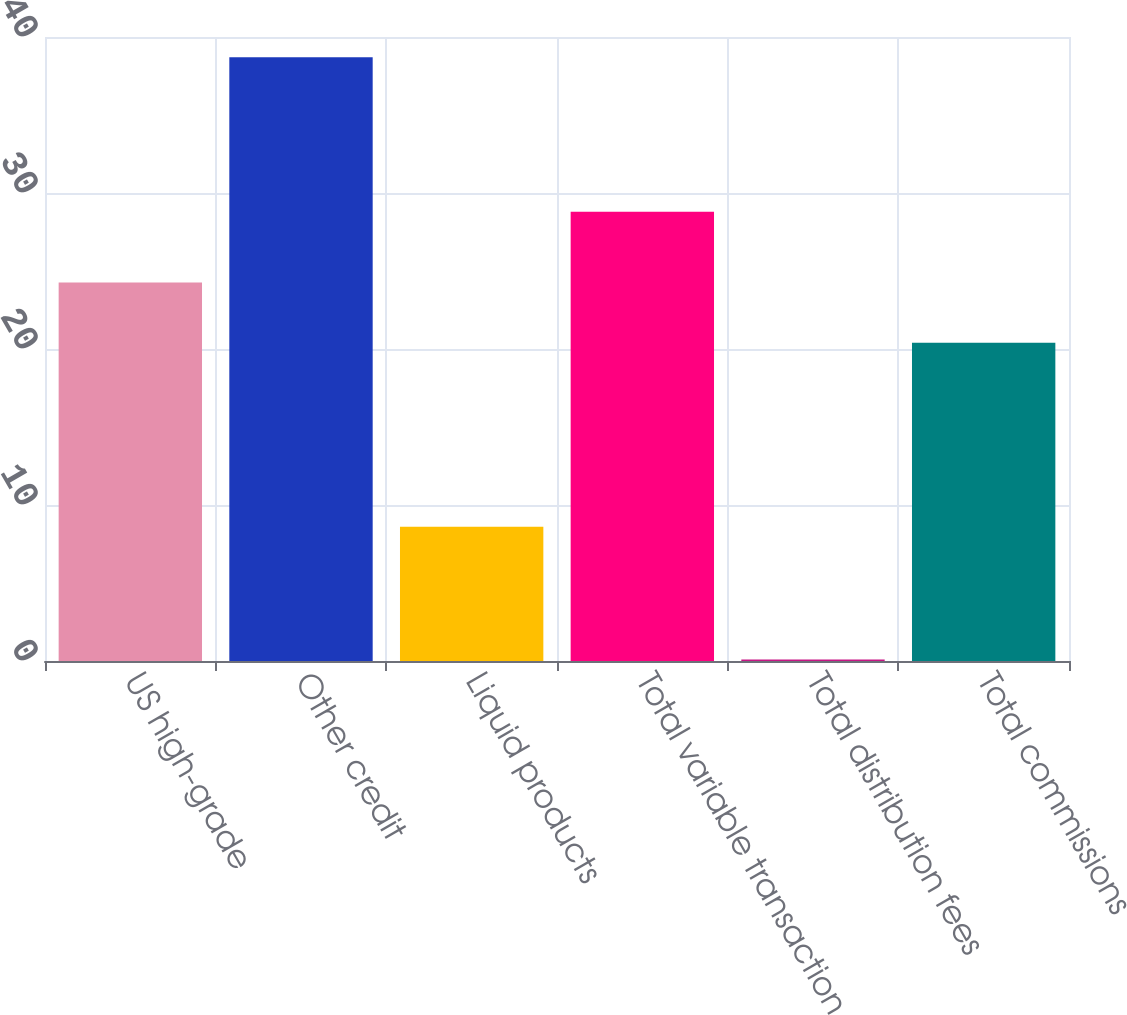<chart> <loc_0><loc_0><loc_500><loc_500><bar_chart><fcel>US high-grade<fcel>Other credit<fcel>Liquid products<fcel>Total variable transaction<fcel>Total distribution fees<fcel>Total commissions<nl><fcel>24.26<fcel>38.7<fcel>8.6<fcel>28.8<fcel>0.1<fcel>20.4<nl></chart> 